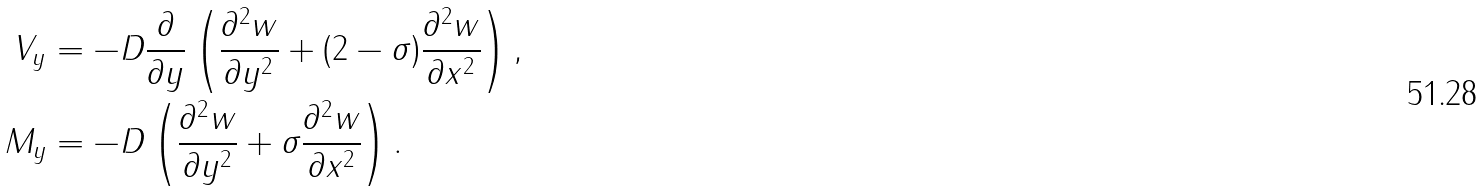Convert formula to latex. <formula><loc_0><loc_0><loc_500><loc_500>V _ { y } & = - D \frac { \partial } { \partial y } \left ( \frac { \partial ^ { 2 } w } { \partial y ^ { 2 } } + ( 2 - \sigma ) \frac { \partial ^ { 2 } w } { \partial x ^ { 2 } } \right ) , \\ M _ { y } & = - D \left ( \frac { \partial ^ { 2 } w } { \partial y ^ { 2 } } + \sigma \frac { \partial ^ { 2 } w } { \partial x ^ { 2 } } \right ) .</formula> 